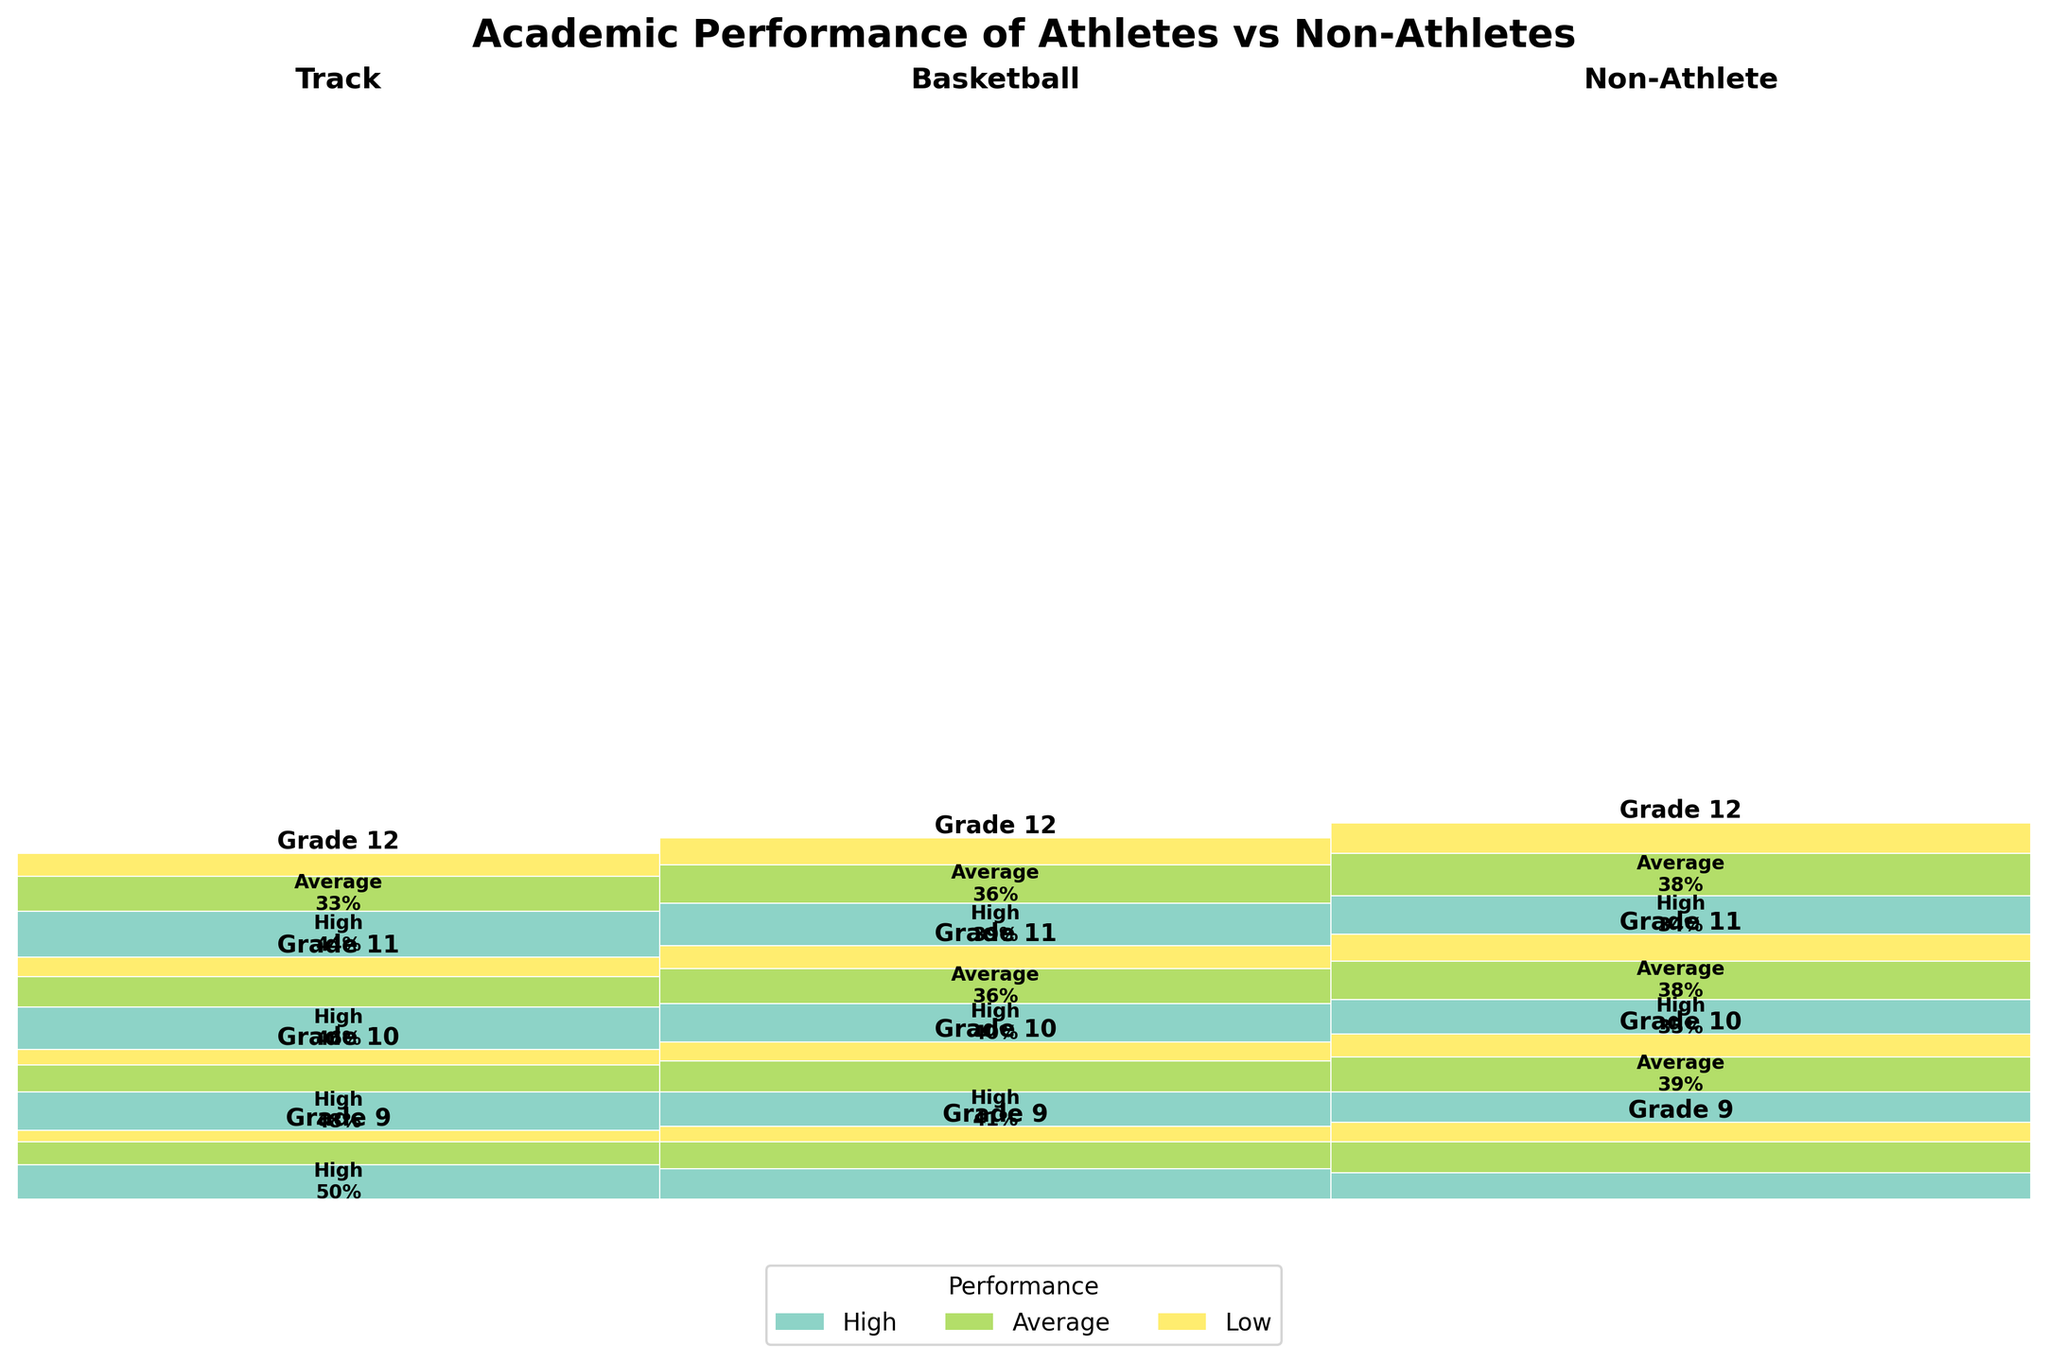What is the title of the figure? The title of the figure is displayed prominently at the top of the mosaic plot, indicating the main subject of the visual representation.
Answer: Academic Performance of Athletes vs Non-Athletes Which sport and grade show the highest proportion of high academic performance? To determine this, we need to look for the largest box within the "High" performance category across all sports and grades. Track in Grade 12 has the largest box in the "High" category.
Answer: Track, Grade 12 What is the difference between the count of low academic performance students in Grade 12 among basketball players and non-athletes? Identify the box representing low performance in Grade 12 for both basketball players and non-athletes. The number of students is 35 for basketball players and 40 for non-athletes. The difference is 40 - 35.
Answer: 5 In Grade 9, which group has the lowest proportion of students with low academic performance? By examining the height of the boxes in the "Low" category for Grade 9, we find that Track athletes have the smallest proportion compared to Basketball players and Non-Athletes.
Answer: Track Is there a noticeable trend in the academic performance of non-athletes as they progress through grades? Look at the "High" category for non-athletes across grades 9 to 12. We observe an increasing trend in the height of the boxes, suggesting an improvement in academic performance.
Answer: Yes, an increasing trend What is the proportional difference in high academic performance between Track athletes and Non-Athletes in Grade 10? Identify the width of the "High" boxes for Track athletes and Non-Athletes in Grade 10. Track athletes have a larger box compared to Non-Athletes. Calculate the proportional difference visually.
Answer: Track athletes perform better in high academic performance Which performance category tends to have the highest counts across all grades and sports? Compare the heights of boxes in the "High," "Average," and "Low" categories. The "High" performance category generally has the highest counts across all sports and grades.
Answer: High How does the academic performance of basketball players in Grade 11 compare to non-athletes in the same grade? Look at the boxes for Grade 11 basketball players and non-athletes. Compare the heights of the "High," "Average," and "Low" categories. Non-athletes have a slightly higher "High" proportion and a smaller "Low" proportion.
Answer: Non-athletes perform slightly better Which sport and grade combination shows the least proportion of students with average academic performance? Locate the smallest box in the "Average" category across all sports and grades. Track athletes in Grade 9 have the smallest box in the "Average" category.
Answer: Track, Grade 9 Overall, do athletes tend to have better academic performance compared to non-athletes? To answer this, review the proportion of "High" performance categories across all sports. Athletes (both Track and Basketball) generally show larger "High" performance boxes compared to non-athletes.
Answer: Yes 